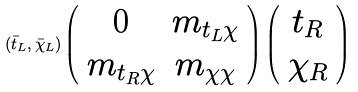<formula> <loc_0><loc_0><loc_500><loc_500>( \bar { t } _ { L } , \bar { \chi } _ { L } ) \left ( \begin{array} { c c } 0 & m _ { t _ { L } \chi } \\ m _ { t _ { R } \chi } & m _ { \chi \chi } \end{array} \right ) \left ( \begin{array} { c } t _ { R } \\ \chi _ { R } \end{array} \right )</formula> 